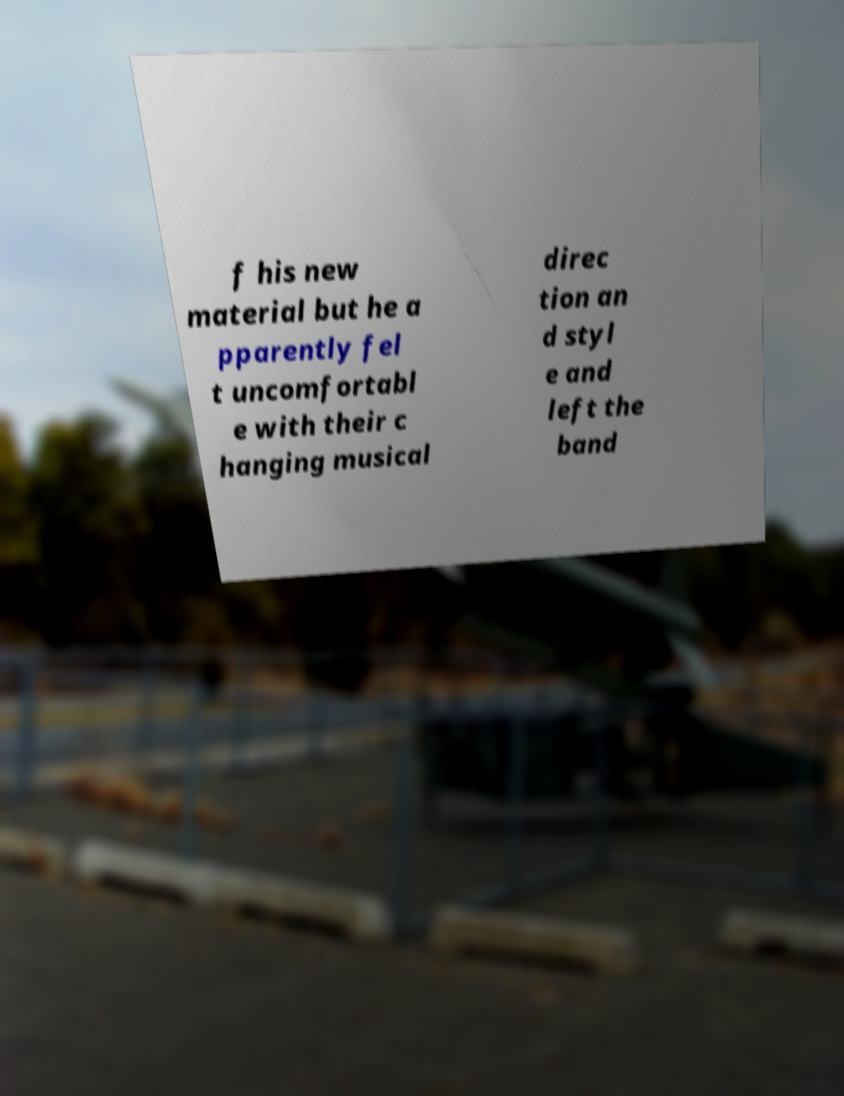Could you extract and type out the text from this image? f his new material but he a pparently fel t uncomfortabl e with their c hanging musical direc tion an d styl e and left the band 